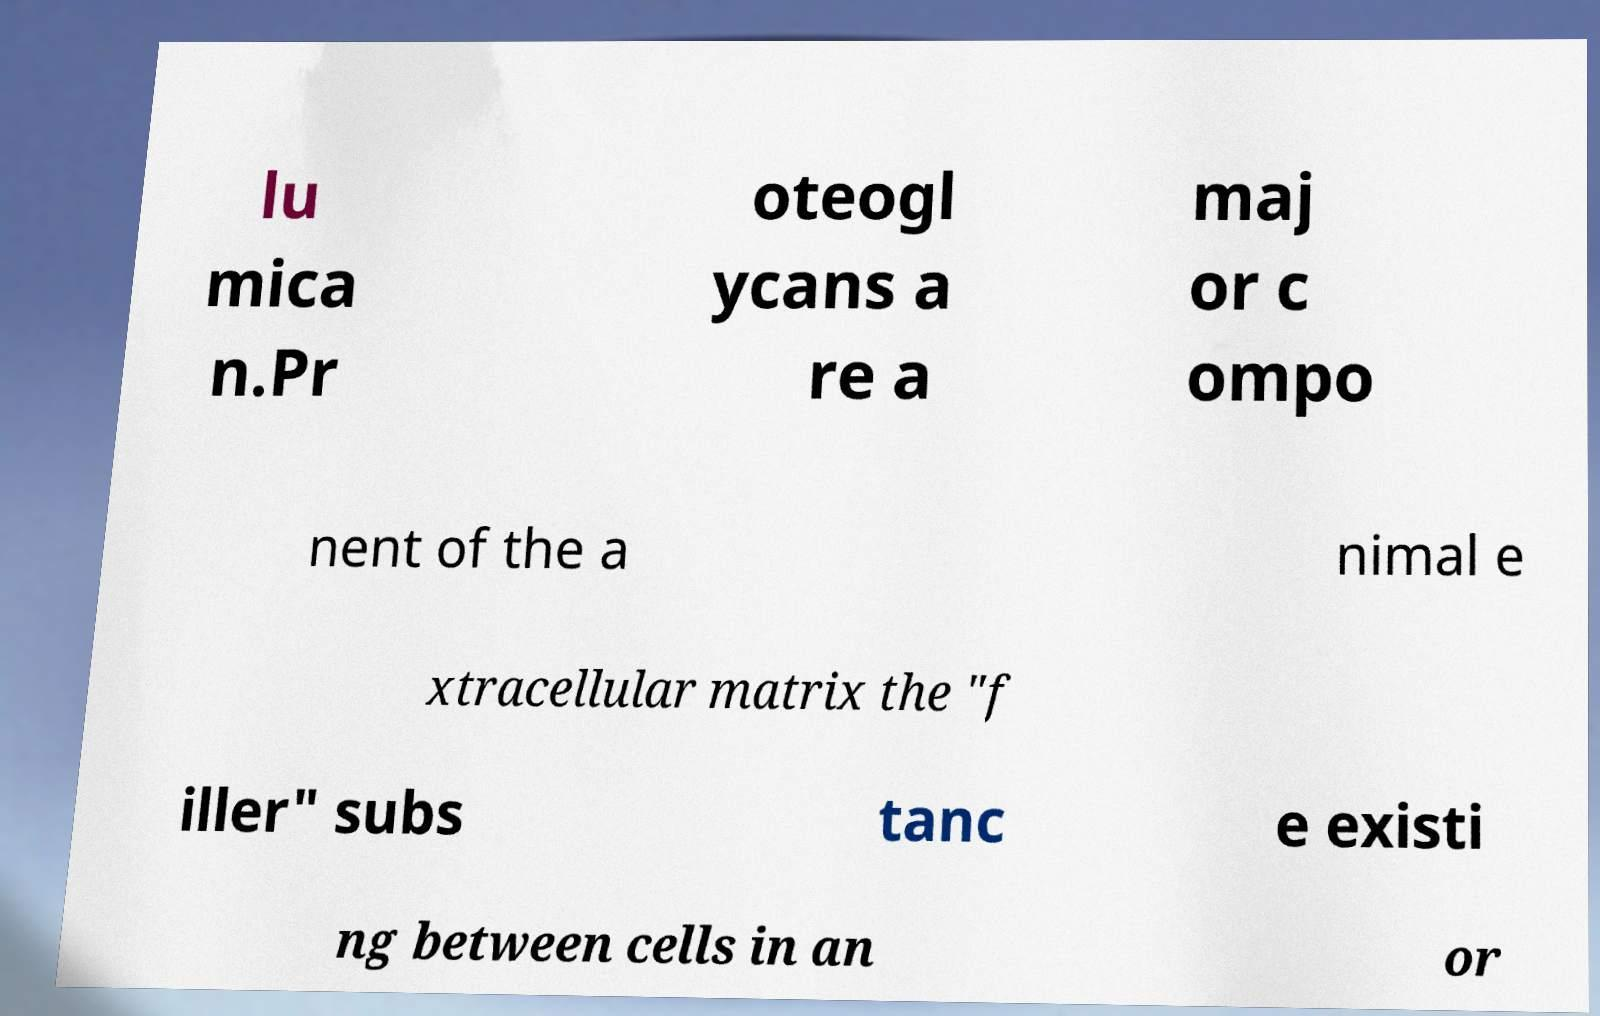Please read and relay the text visible in this image. What does it say? lu mica n.Pr oteogl ycans a re a maj or c ompo nent of the a nimal e xtracellular matrix the "f iller" subs tanc e existi ng between cells in an or 